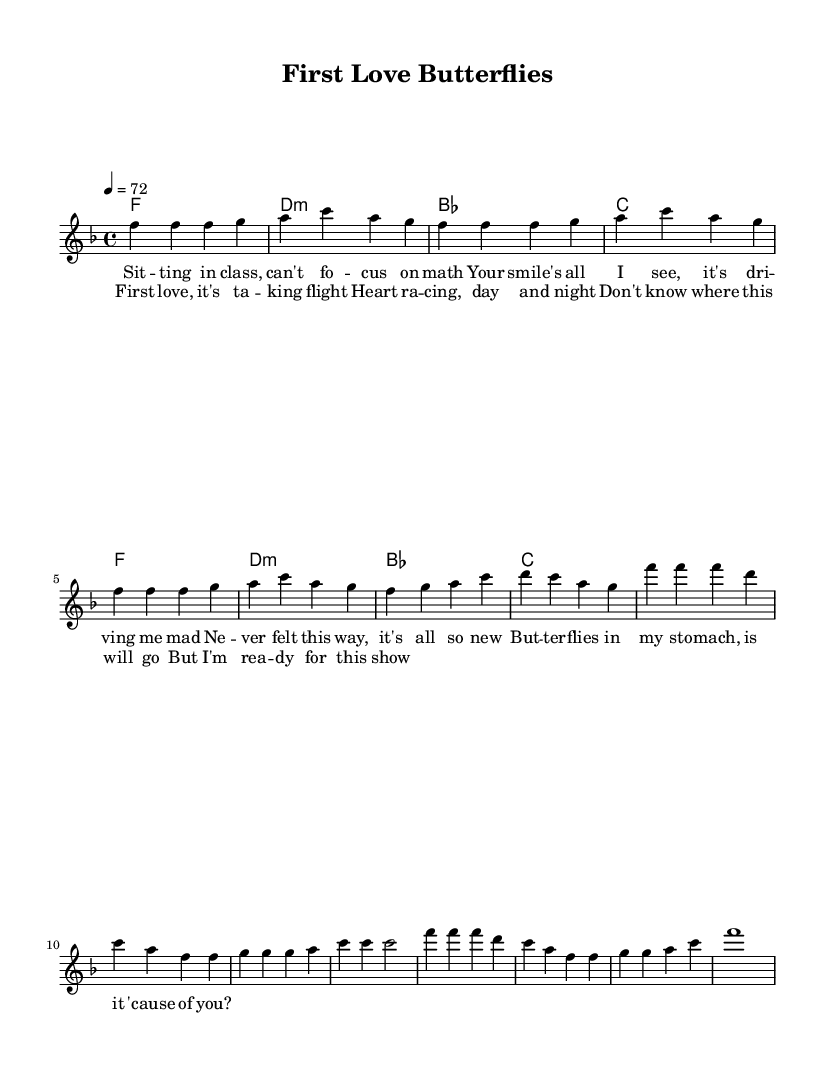What is the key signature of this music? The key signature is F major, which has one flat (B flat).
Answer: F major What is the time signature of this piece? The time signature indicated in the sheet music is 4/4, meaning there are four beats in each measure.
Answer: 4/4 What is the tempo marking for this piece? The tempo marking indicates a speed of 72 beats per minute, meaning 72 quarter notes will be played in one minute.
Answer: 72 How many measures are in the verse? The verse consists of 8 measures, as counted from the beginning to the end of that section in the melody.
Answer: 8 Which chord is played for the chorus? The first chord of the chorus is F, indicated at the start of the chord progression.
Answer: F What is the emotional theme of the lyrics? The lyrics convey a feeling of first love with excitement and nervousness, indicated by phrases like "heart racing" and "butterflies in my stomach."
Answer: Excitement What distinguishes Rhythm and Blues love songs in this music? This piece reflects typical themes of adolescence and vulnerability in love, emphasizing emotional expression and personal experiences which is characteristic of Rhythm and Blues.
Answer: Emotional expression 